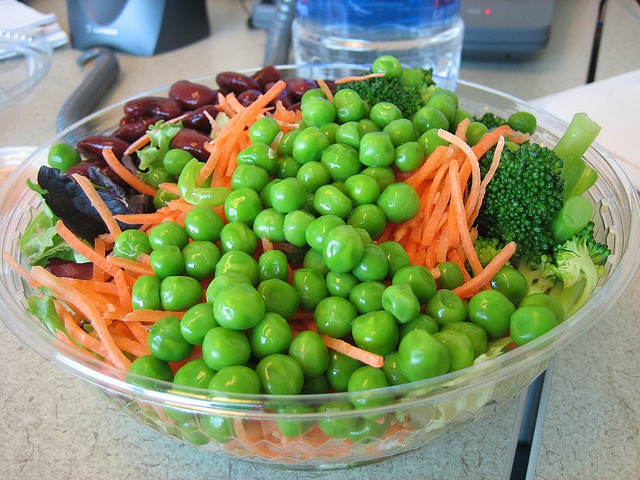Describe the objects in this image and their specific colors. I can see bowl in lavender, green, darkgreen, darkgray, and black tones, dining table in lavender, darkgray, lightgray, and gray tones, carrot in lavender, orange, red, and tan tones, bottle in lavender, blue, gray, and lightblue tones, and carrot in lavender, red, orange, and brown tones in this image. 